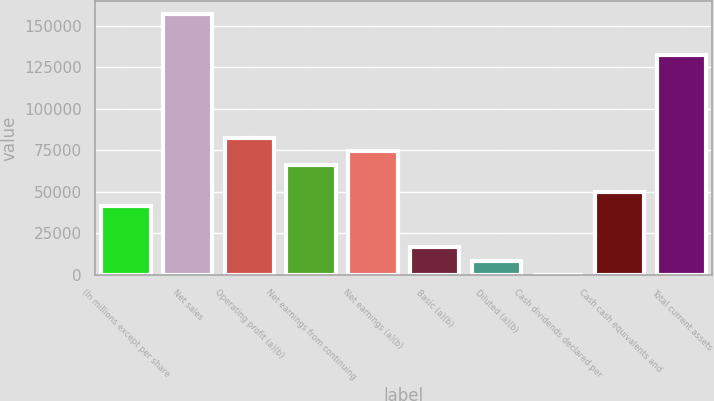Convert chart. <chart><loc_0><loc_0><loc_500><loc_500><bar_chart><fcel>(In millions except per share<fcel>Net sales<fcel>Operating profit (a)(b)<fcel>Net earnings from continuing<fcel>Net earnings (a)(b)<fcel>Basic (a)(b)<fcel>Diluted (a)(b)<fcel>Cash dividends declared per<fcel>Cash cash equivalents and<fcel>Total current assets<nl><fcel>41302.4<fcel>156936<fcel>82600<fcel>66080.9<fcel>74340.5<fcel>16523.8<fcel>8264.3<fcel>4.78<fcel>49561.9<fcel>132157<nl></chart> 